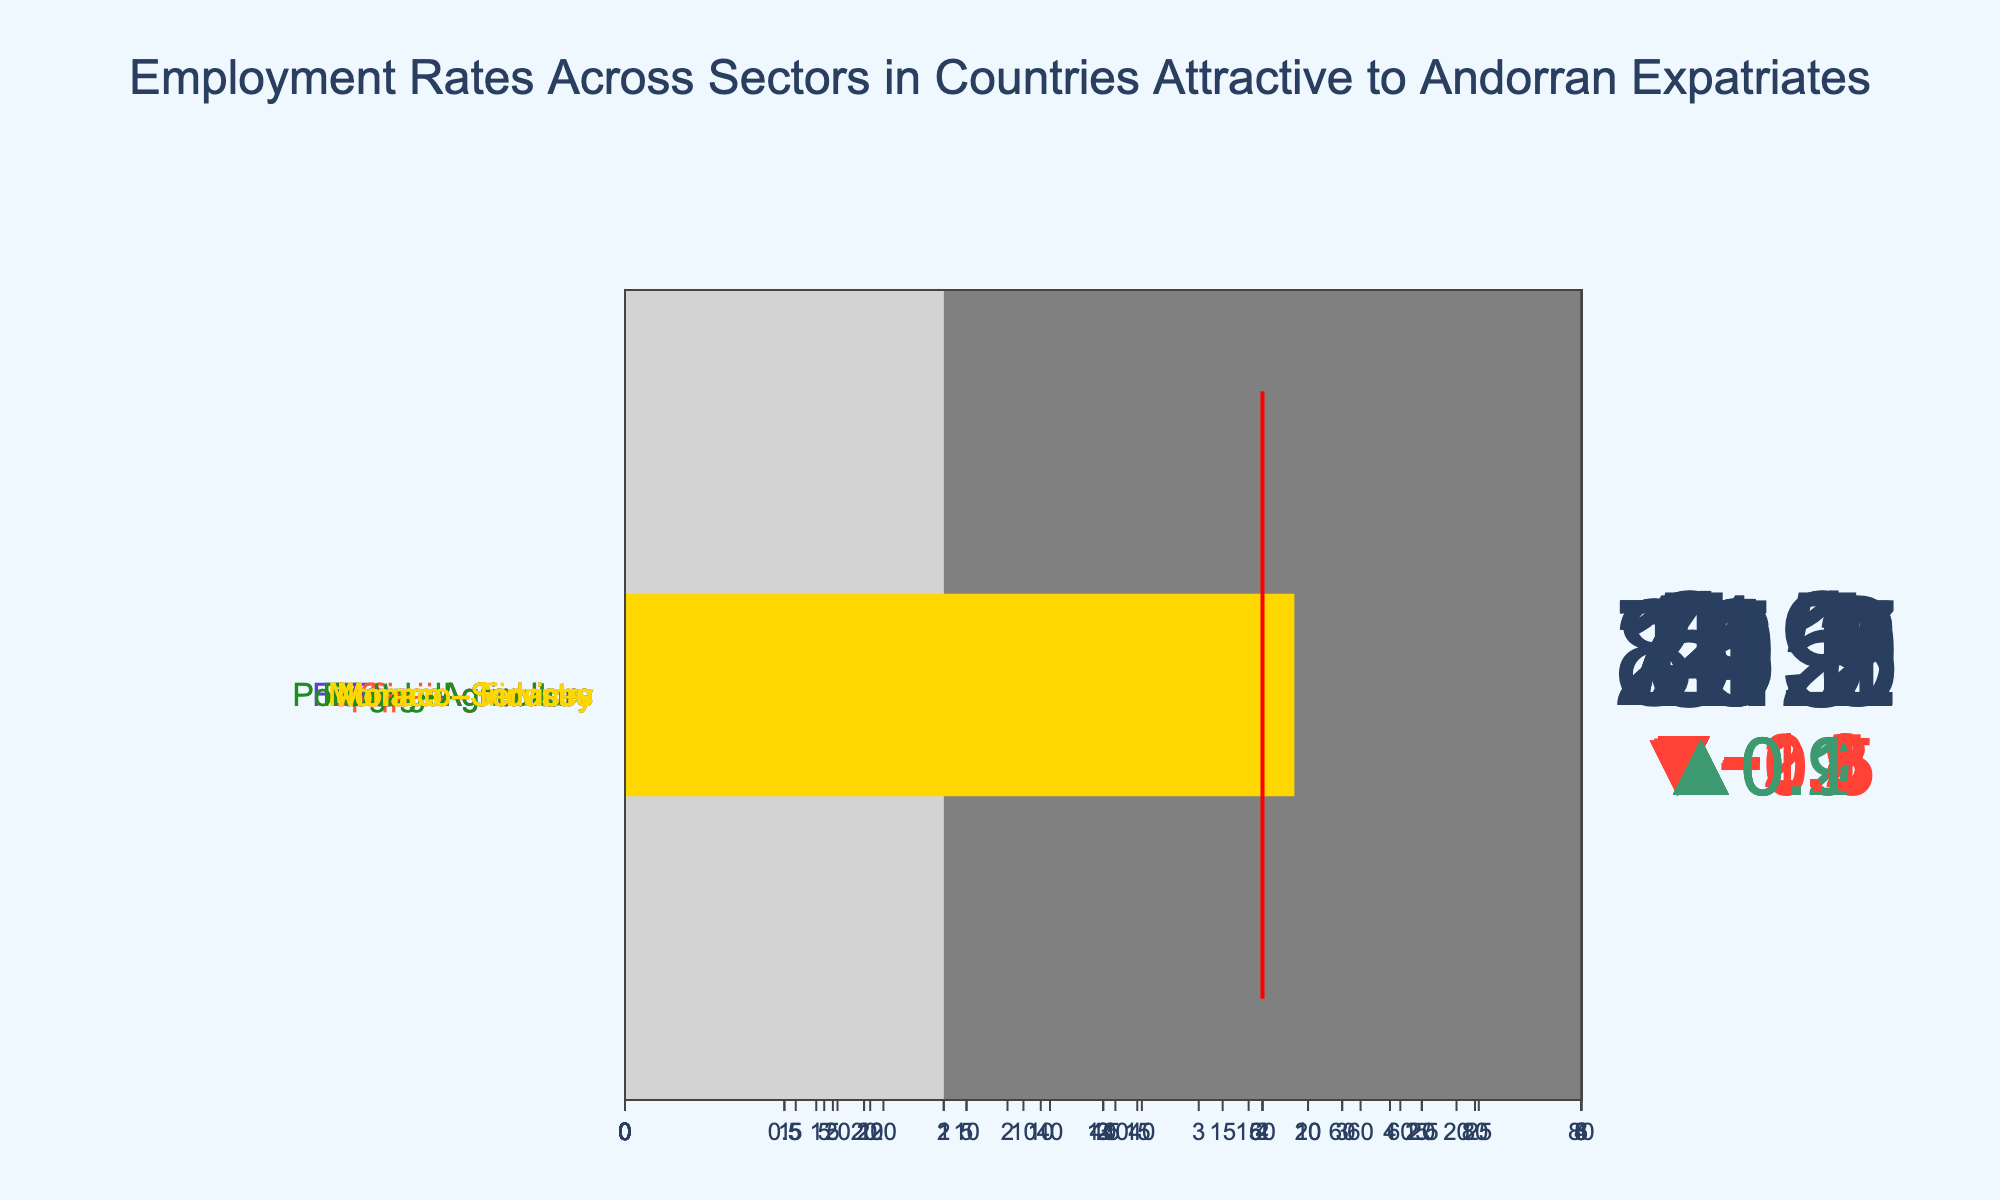What is the current employment rate in the Services sector in France? The figure displays a current employment rate of 75.8 for the Services sector in France as indicated directly on the bullet chart.
Answer: 75.8 Is the current employment rate in the Industry sector of Portugal above or below the target? The current employment rate in the Industry sector of Portugal is 24.7, while the target is 26. Since 24.7 is less than 26, it is below the target.
Answer: Below What is the comparative range of the Agriculture sector in Spain? The Agriculture sector in Spain has a comparative range starting at 3 and ending at 5, as shown on the bullet chart.
Answer: 3 to 5 Which country has the highest current employment rate in the Services sector? The countries' current employment rates for the Services sector are: France (75.8), Spain (74.2), Portugal (70.1), and Monaco (86.5). Monaco has the highest current employment rate in the Services sector at 86.5.
Answer: Monaco How much higher is the target employment rate for Agriculture in Portugal compared to the actual rate? The current employment rate for Agriculture in Portugal is 5.9, and the target is 5. The difference between the two is 5.9 - 5 = 0.9.
Answer: 0.9 Compare the current employment rates for the Industry sector across Spain and France; which country has a higher rate, and by how much? Spain's current employment rate in the Industry sector is 19.9, while France's rate is 20.1. France's employment rate is higher by 0.2.
Answer: France by 0.2 What is the threshold value for the Finance sector in Monaco? The target employment rate, indicated by the threshold line, for the Finance sector in Monaco is 12.
Answer: 12 In which country-sectors is the current employment rate exactly matching the target rate? By reviewing each country’s sector data, it can be observed that Monaco's Industry sector has a current employment rate and target employment rate both at 2.0.
Answer: Monaco - Industry What is the overall range for the Industry sector in Spain? The range for the Industry sector in Spain starts at 18 and ends at 23, representing the total comparative range for this sector.
Answer: 18 to 23 Find the difference between the highest and lowest current employment rates in the Services sector among the countries. The Services sector current rates are: France (75.8), Spain (74.2), Portugal (70.1), Monaco (86.5). The difference between the highest (Monaco, 86.5) and the lowest (Portugal, 70.1) is 86.5 - 70.1 = 16.4.
Answer: 16.4 